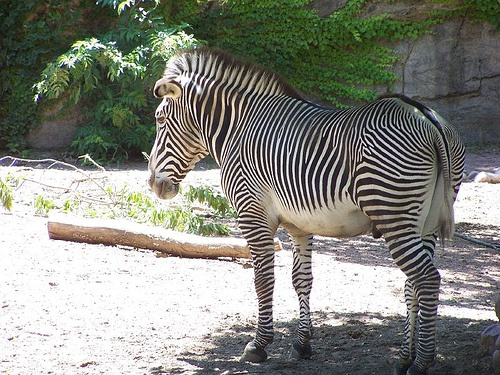Describe the objects in this image and their specific colors. I can see a zebra in black, gray, darkgray, and lightgray tones in this image. 